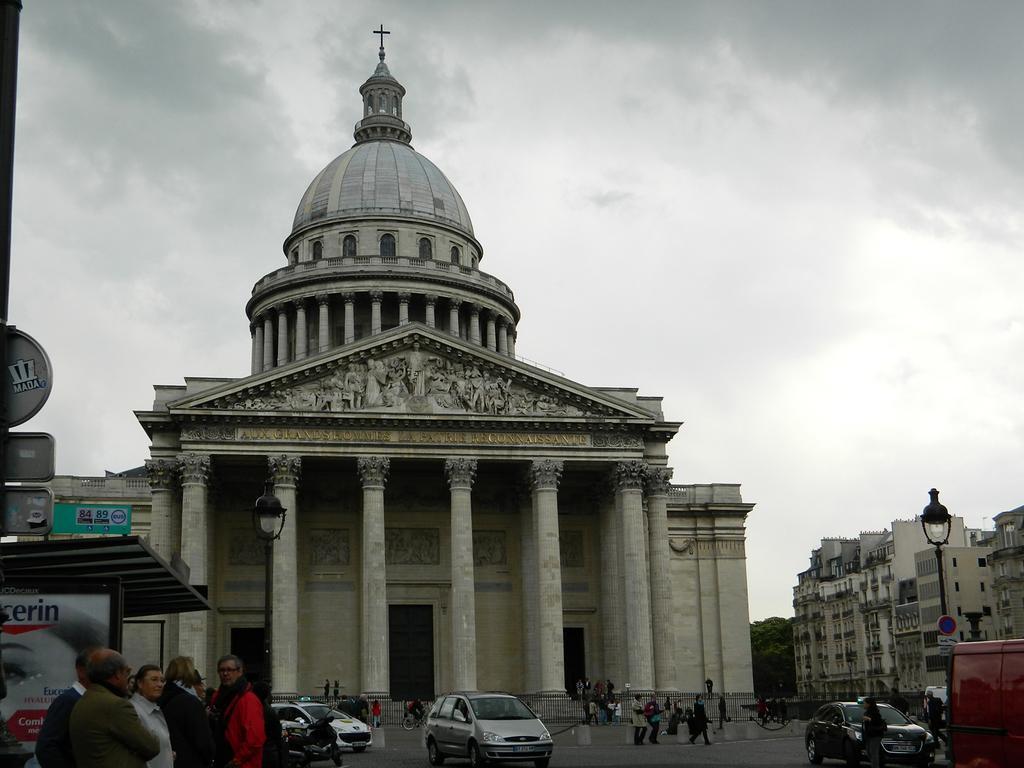In one or two sentences, can you explain what this image depicts? There are few persons standing in the left corner and there are few vehicles beside them and there are buildings in the background and the sky is cloudy. 